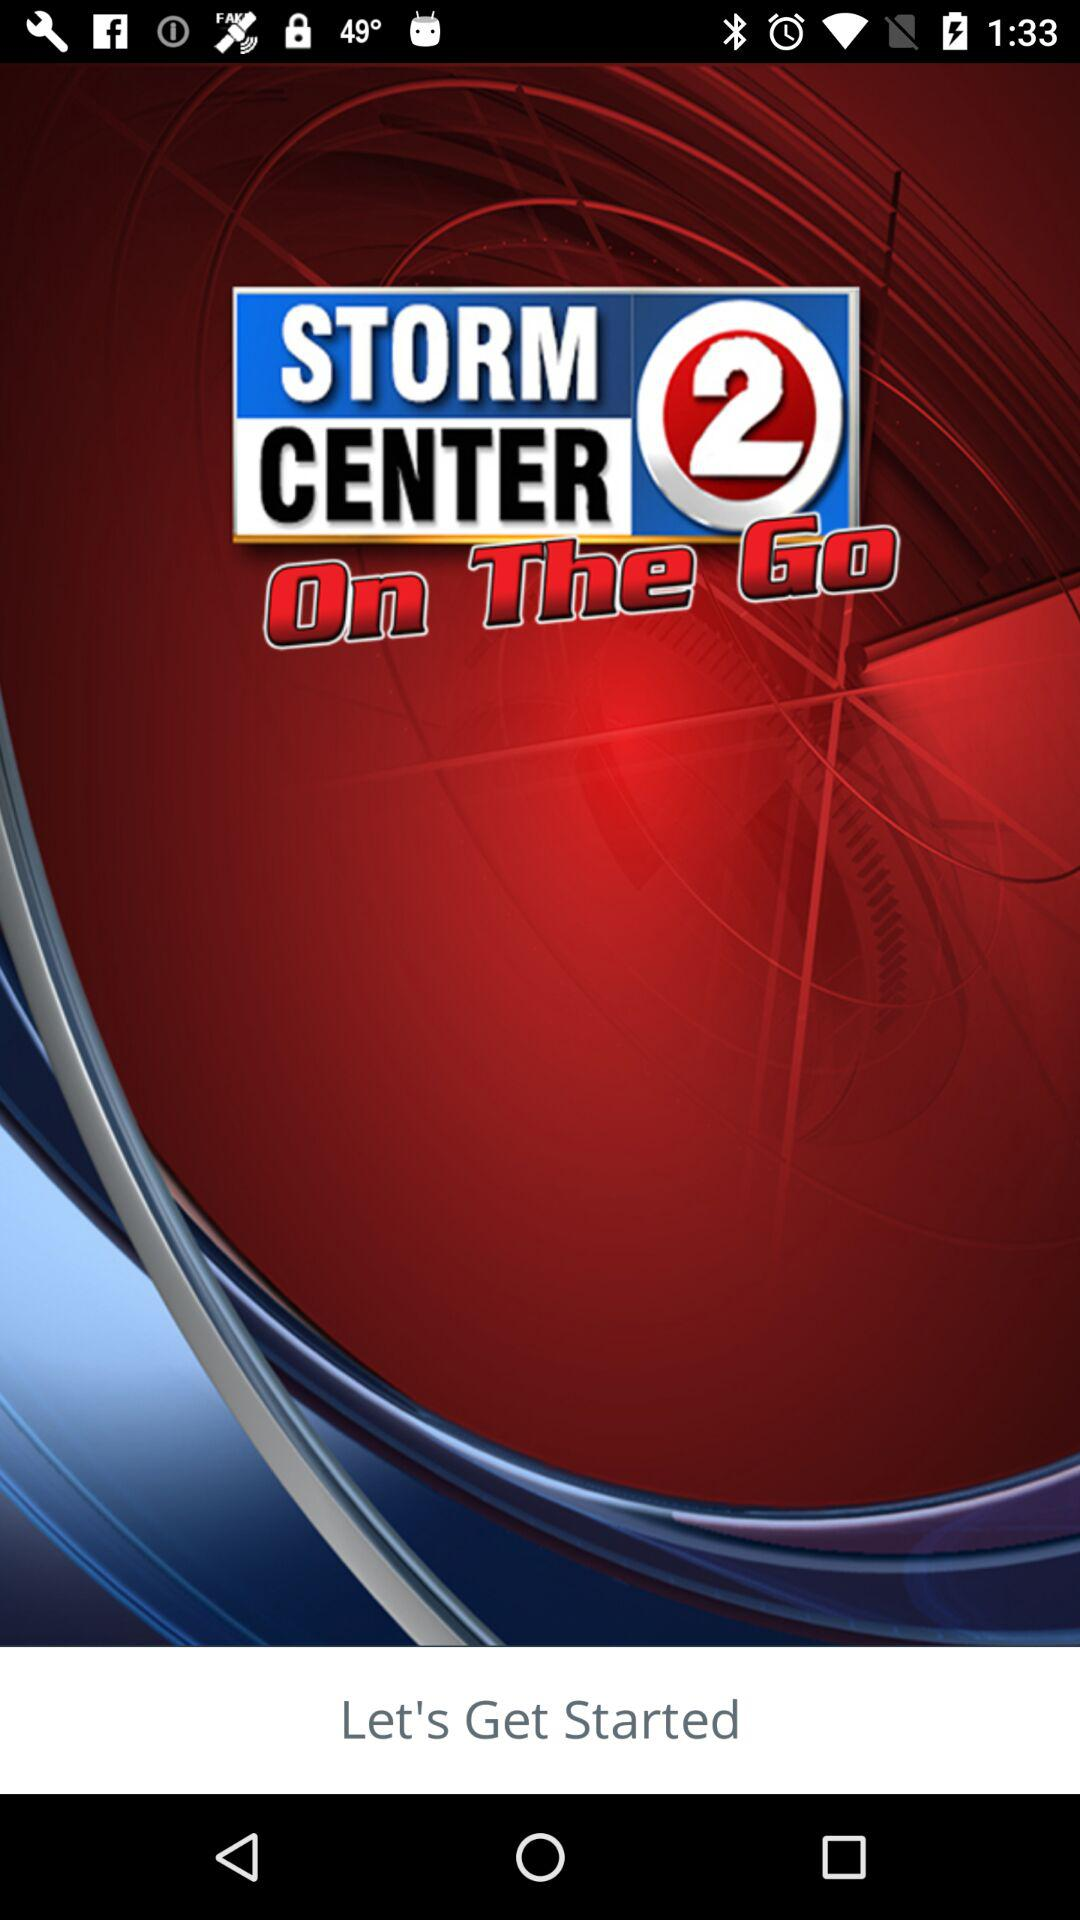Will it be sunny tomorrow?
When the provided information is insufficient, respond with <no answer>. <no answer> 